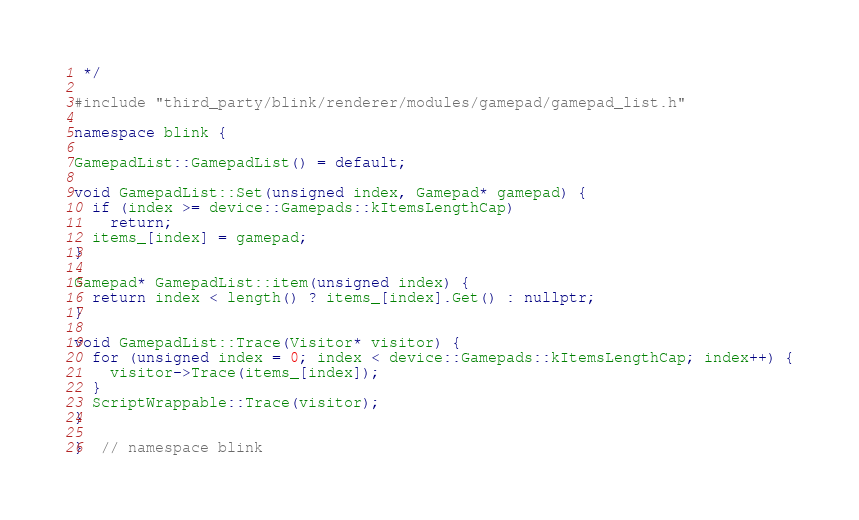Convert code to text. <code><loc_0><loc_0><loc_500><loc_500><_C++_> */

#include "third_party/blink/renderer/modules/gamepad/gamepad_list.h"

namespace blink {

GamepadList::GamepadList() = default;

void GamepadList::Set(unsigned index, Gamepad* gamepad) {
  if (index >= device::Gamepads::kItemsLengthCap)
    return;
  items_[index] = gamepad;
}

Gamepad* GamepadList::item(unsigned index) {
  return index < length() ? items_[index].Get() : nullptr;
}

void GamepadList::Trace(Visitor* visitor) {
  for (unsigned index = 0; index < device::Gamepads::kItemsLengthCap; index++) {
    visitor->Trace(items_[index]);
  }
  ScriptWrappable::Trace(visitor);
}

}  // namespace blink
</code> 